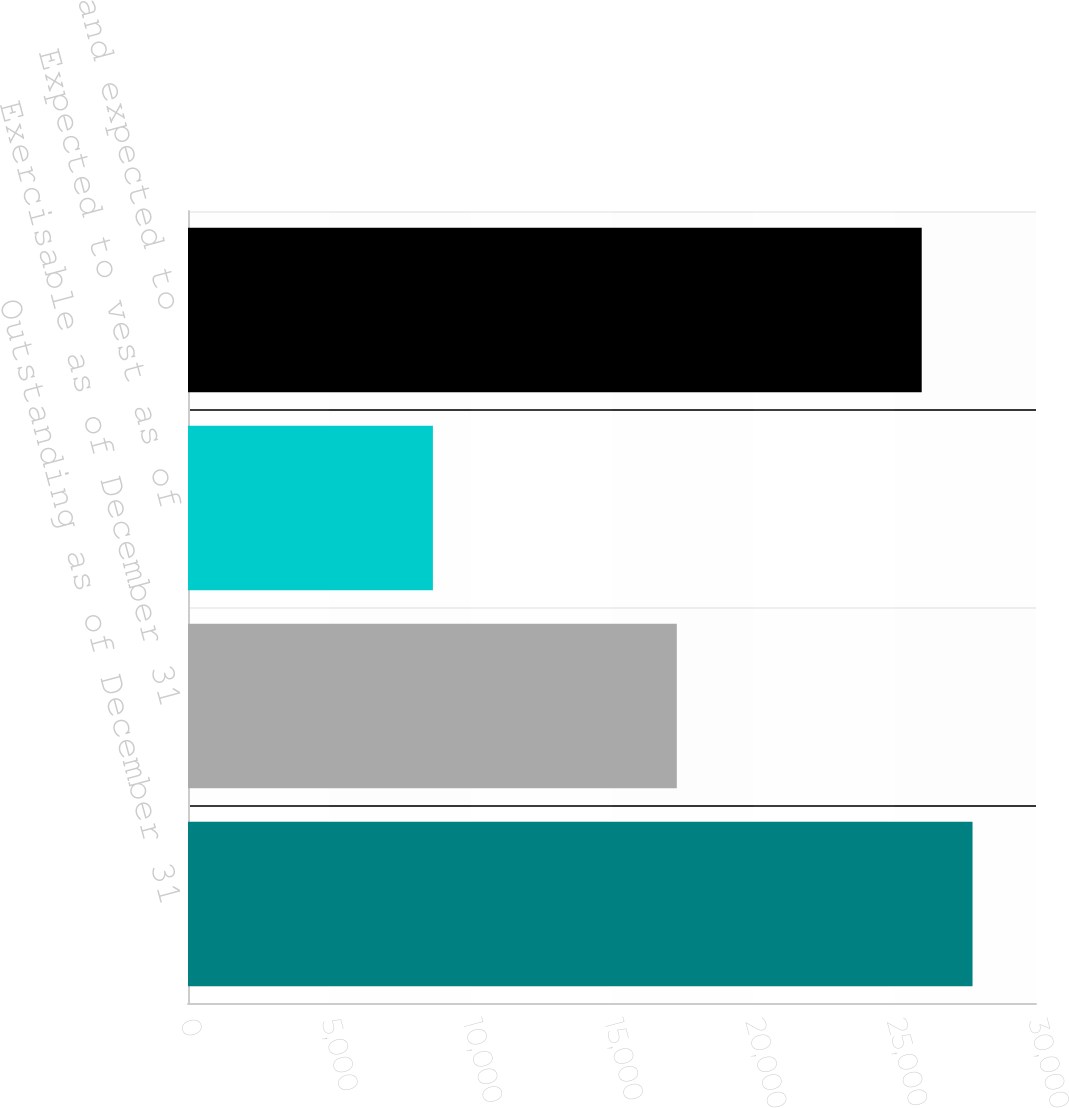Convert chart to OTSL. <chart><loc_0><loc_0><loc_500><loc_500><bar_chart><fcel>Outstanding as of December 31<fcel>Exercisable as of December 31<fcel>Expected to vest as of<fcel>Total vested and expected to<nl><fcel>27755<fcel>17293<fcel>8664<fcel>25957<nl></chart> 